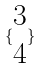<formula> <loc_0><loc_0><loc_500><loc_500>\{ \begin{matrix} 3 \\ 4 \end{matrix} \}</formula> 